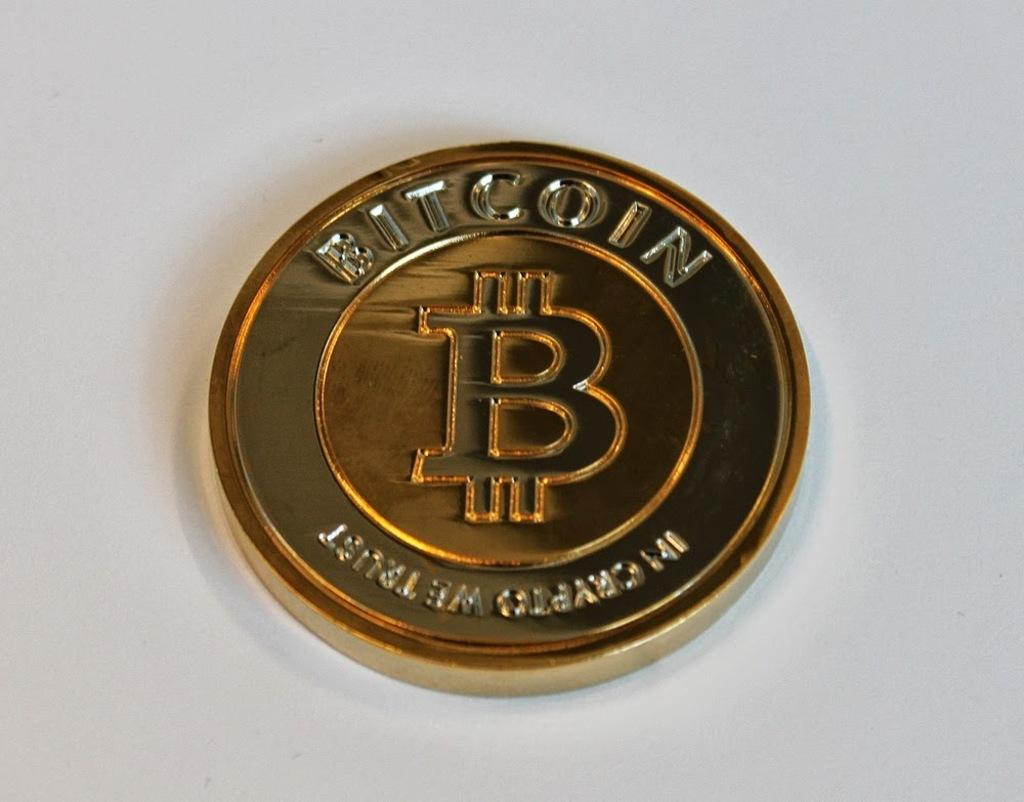Provide a one-sentence caption for the provided image. a coin that has a symbol on it and says 'bitcoin' at the top. 